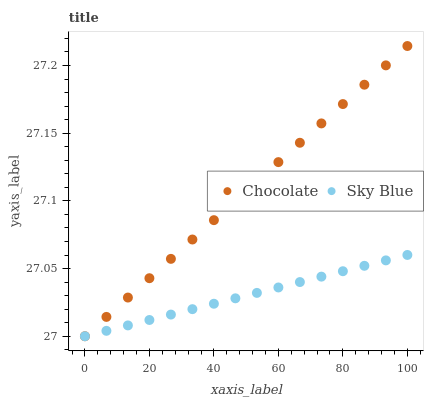Does Sky Blue have the minimum area under the curve?
Answer yes or no. Yes. Does Chocolate have the maximum area under the curve?
Answer yes or no. Yes. Does Chocolate have the minimum area under the curve?
Answer yes or no. No. Is Sky Blue the smoothest?
Answer yes or no. Yes. Is Chocolate the roughest?
Answer yes or no. Yes. Is Chocolate the smoothest?
Answer yes or no. No. Does Sky Blue have the lowest value?
Answer yes or no. Yes. Does Chocolate have the highest value?
Answer yes or no. Yes. Does Chocolate intersect Sky Blue?
Answer yes or no. Yes. Is Chocolate less than Sky Blue?
Answer yes or no. No. Is Chocolate greater than Sky Blue?
Answer yes or no. No. 